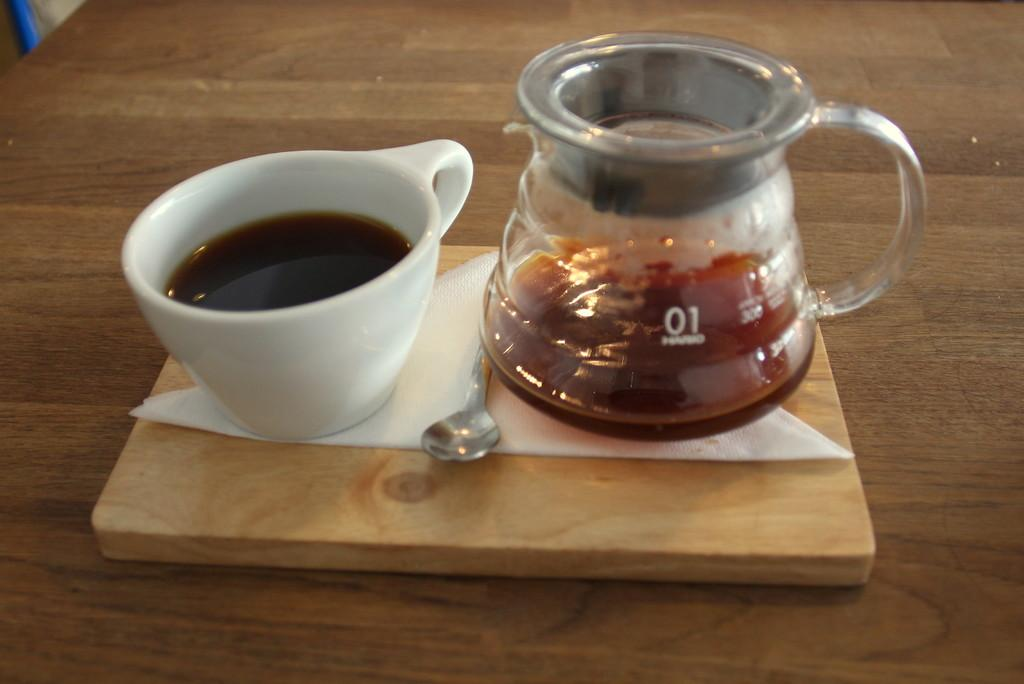What can be seen in the cups in the image? There are two cups with liquid in the image. What utensil is present in the image? There is a spoon in the image. Where is the spoon placed? The spoon is on a tissue paper. What is the tissue paper placed on? The tissue paper is on a wooden board. What is the wooden board placed on? The wooden board is on a platform. What is located in the left top corner of the image? There is an object in the left top corner of the image. How many pizzas are being served on the wooden board in the image? There are no pizzas present in the image; the wooden board has a tissue paper and a spoon on it. Can you see a hand holding the spoon in the image? There is no hand visible in the image; the spoon is placed on a tissue paper. 